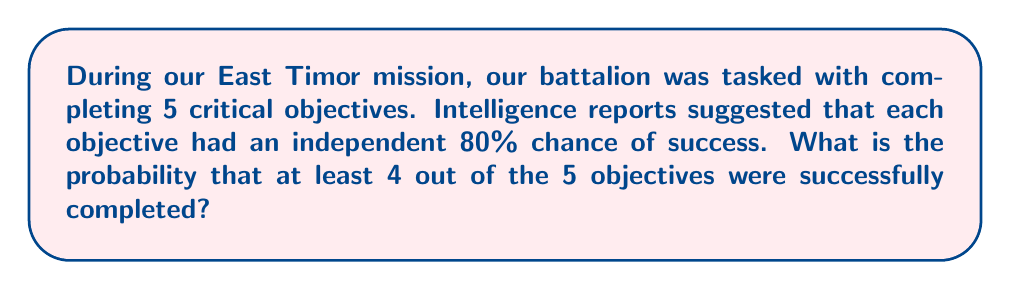Can you solve this math problem? Let's approach this step-by-step using combinatorics and probability theory:

1) First, we need to identify the probability of success for each objective:
   $p(\text{success}) = 0.80$ or $80\%$
   $p(\text{failure}) = 1 - 0.80 = 0.20$ or $20\%$

2) We want the probability of at least 4 successes out of 5 objectives. This can happen in two ways:
   a) Exactly 4 successes and 1 failure
   b) All 5 successes

3) Let's calculate the probability of exactly 4 successes:
   - We need to choose which 4 out of 5 will be successful: $\binom{5}{4}$ ways
   - Probability: $\binom{5}{4} \cdot 0.80^4 \cdot 0.20^1$

4) Now, let's calculate the probability of all 5 successes:
   - Probability: $0.80^5$

5) The total probability is the sum of these two scenarios:

   $$P(\text{at least 4 successes}) = \binom{5}{4} \cdot 0.80^4 \cdot 0.20^1 + 0.80^5$$

6) Let's compute each part:
   - $\binom{5}{4} = 5$
   - $0.80^4 \cdot 0.20^1 = 0.4096 \cdot 0.20 = 0.08192$
   - $0.80^5 = 0.32768$

7) Putting it all together:
   $$P(\text{at least 4 successes}) = 5 \cdot 0.08192 + 0.32768 = 0.40960 + 0.32768 = 0.73728$$
Answer: The probability that at least 4 out of the 5 objectives were successfully completed is $0.73728$ or approximately $73.73\%$. 